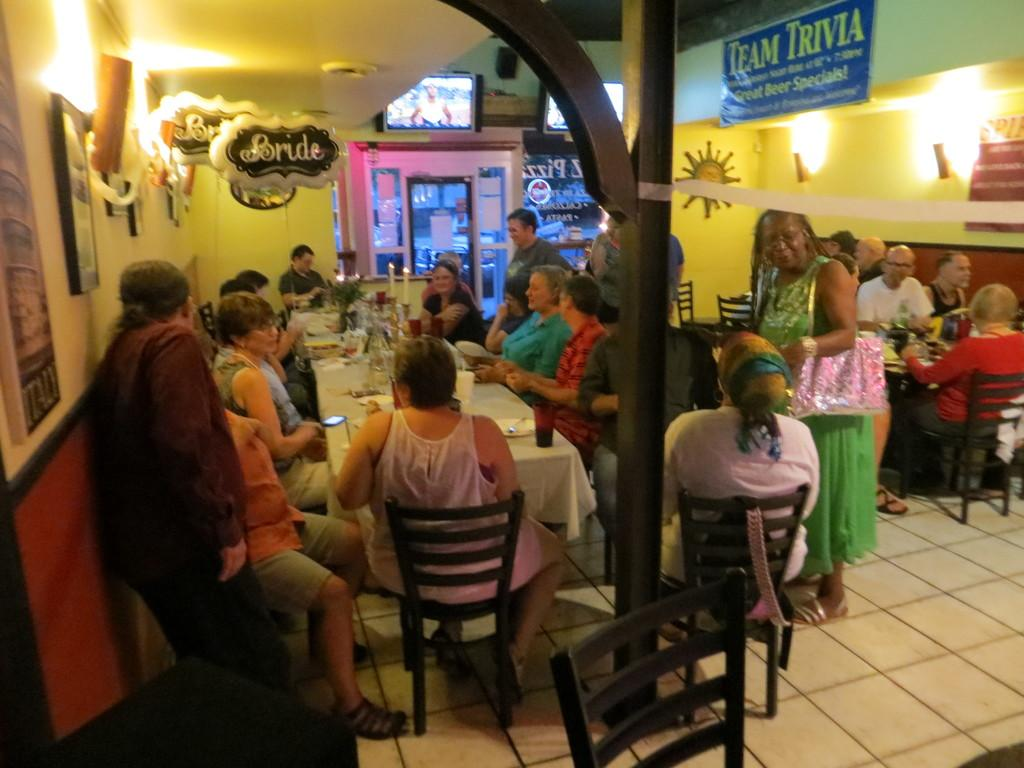What are the people in the image doing? The people are sitting around a dining table and having food. Can you describe the setting of the image? The people are sitting around a dining table, which suggests they are in a dining area or a similar setting. What can be seen in the background of the image? In the background, there are balloons hanging. What type of statement can be seen written on the wall in the image? There is no statement visible on the wall in the image; only people having food and balloons hanging in the background are present. 